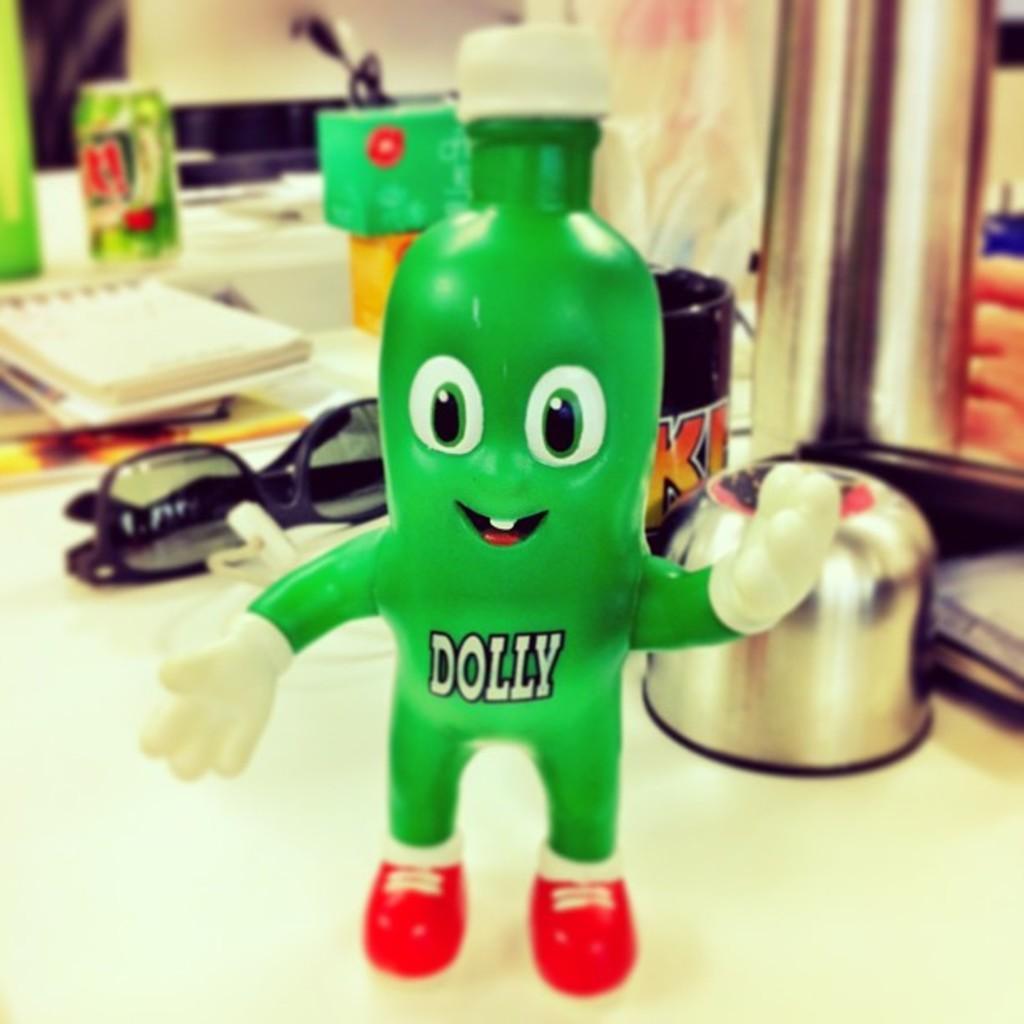Can you describe this image briefly? In the picture there are some papers, doll, cake tin, goggles and other items on a table. 